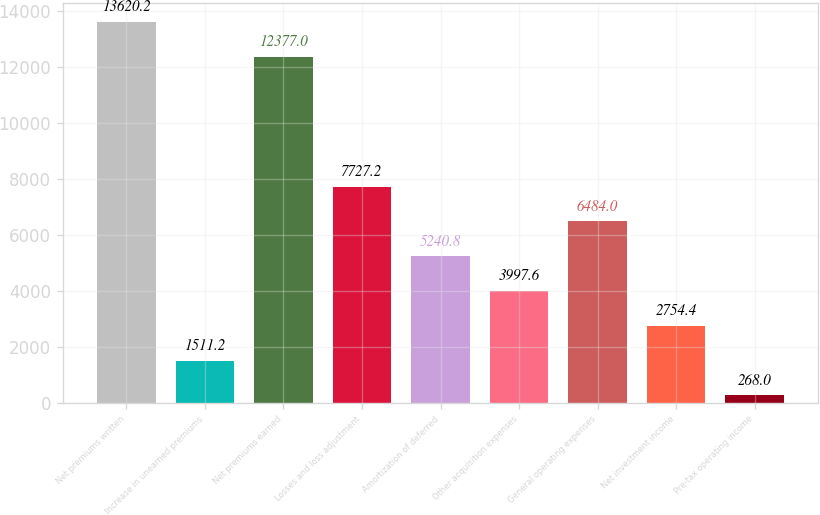<chart> <loc_0><loc_0><loc_500><loc_500><bar_chart><fcel>Net premiums written<fcel>Increase in unearned premiums<fcel>Net premiums earned<fcel>Losses and loss adjustment<fcel>Amortization of deferred<fcel>Other acquisition expenses<fcel>General operating expenses<fcel>Net investment income<fcel>Pre-tax operating income<nl><fcel>13620.2<fcel>1511.2<fcel>12377<fcel>7727.2<fcel>5240.8<fcel>3997.6<fcel>6484<fcel>2754.4<fcel>268<nl></chart> 